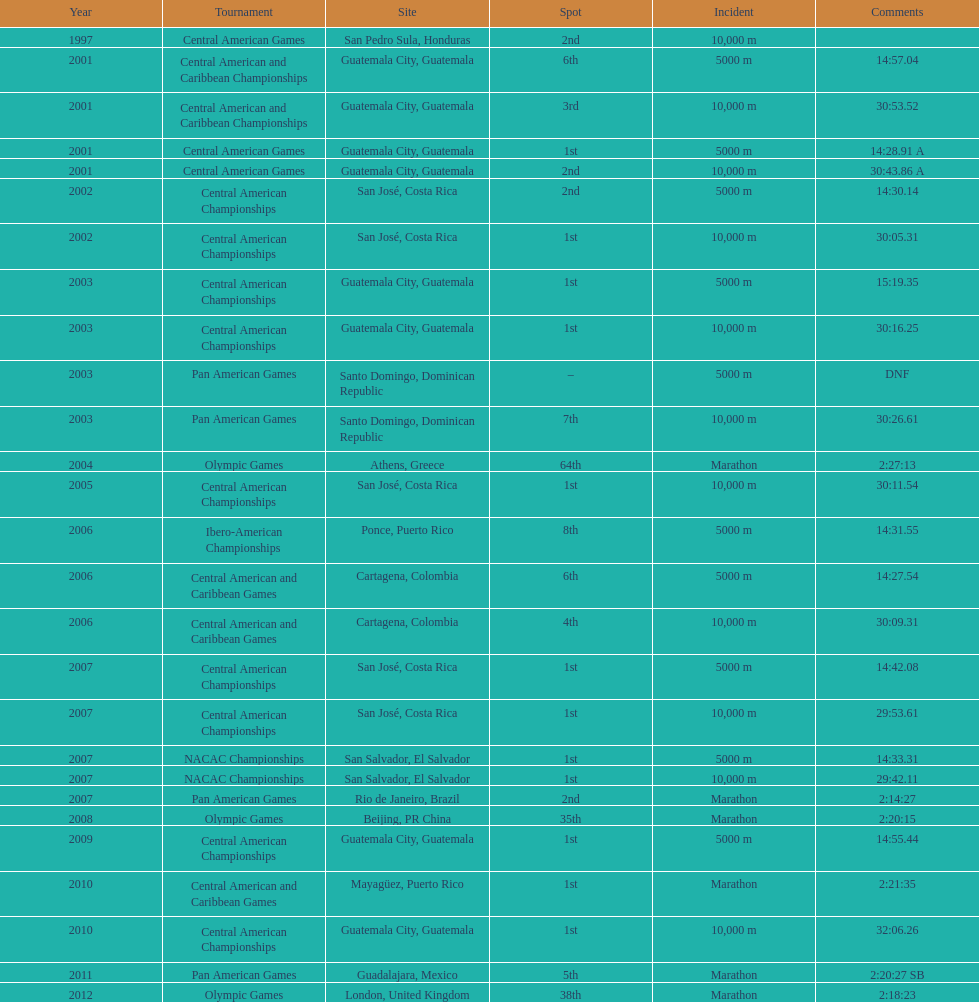The central american championships and what other competition occurred in 2010? Central American and Caribbean Games. 